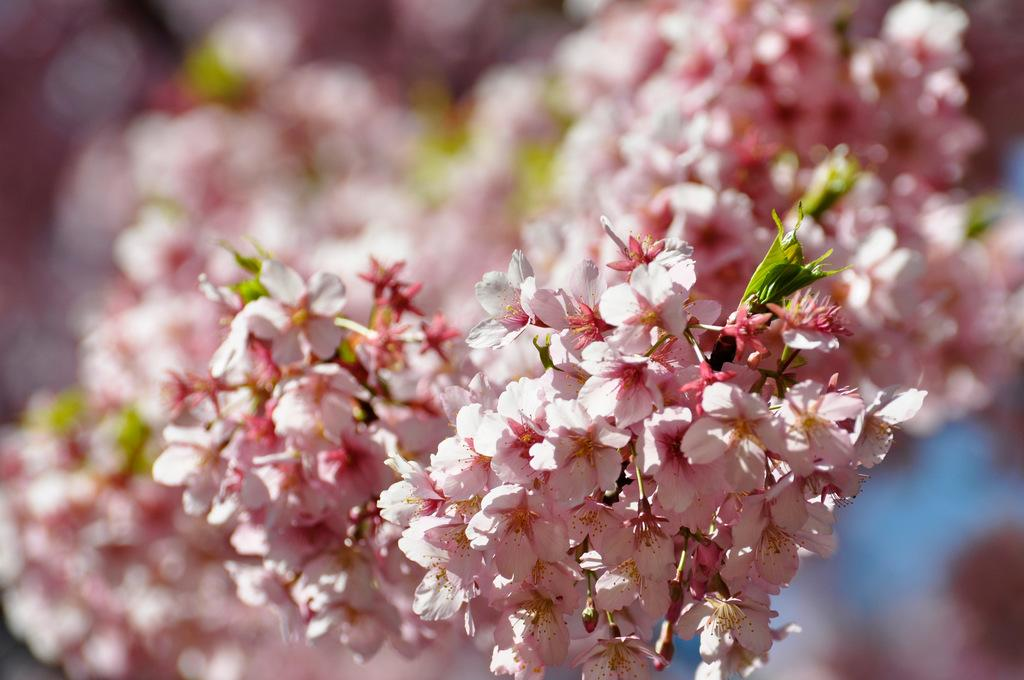What is the main subject of the image? There is a bunch of flowers in the image. What color are the flowers? The flowers are light pink in color. Can you describe any other part of the flowers? There is a leaf visible in the image. How would you describe the background of the image? The background of the image appears blurry. What type of furniture can be seen in the image? There is no furniture present in the image; it features a bunch of light pink flowers with a leaf and a blurry background. 